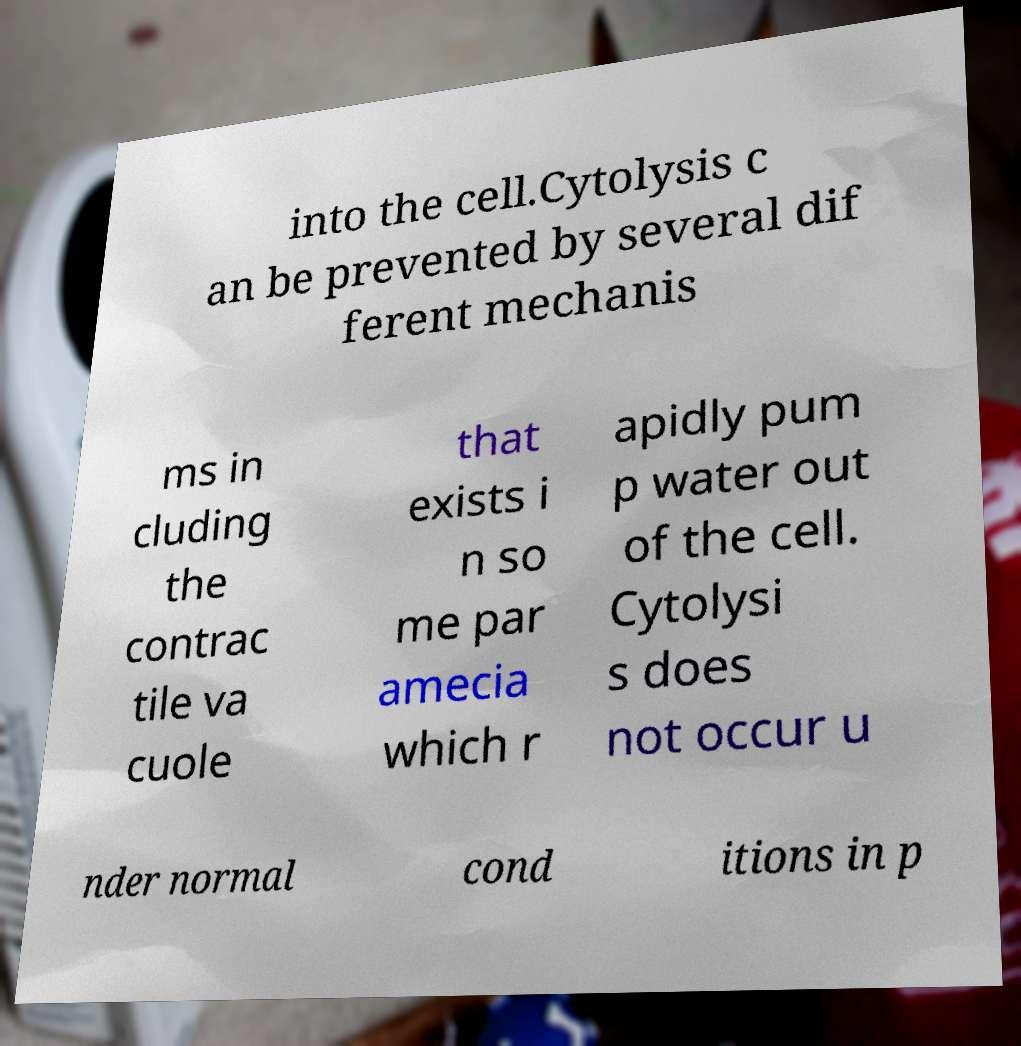What messages or text are displayed in this image? I need them in a readable, typed format. into the cell.Cytolysis c an be prevented by several dif ferent mechanis ms in cluding the contrac tile va cuole that exists i n so me par amecia which r apidly pum p water out of the cell. Cytolysi s does not occur u nder normal cond itions in p 